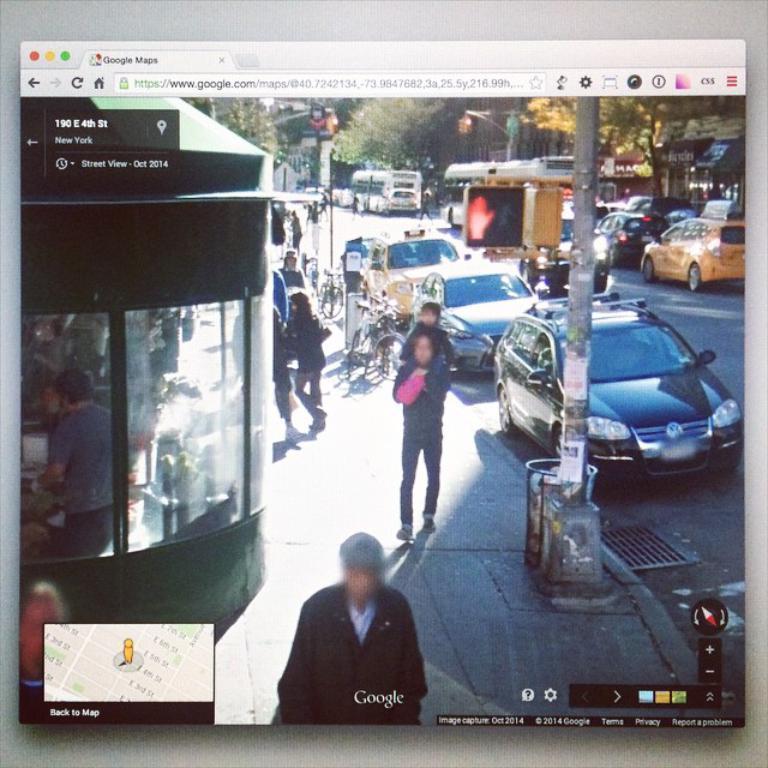Describe this image in one or two sentences. Vehicles are on the road. Here we can see people, pole, trees and store. 